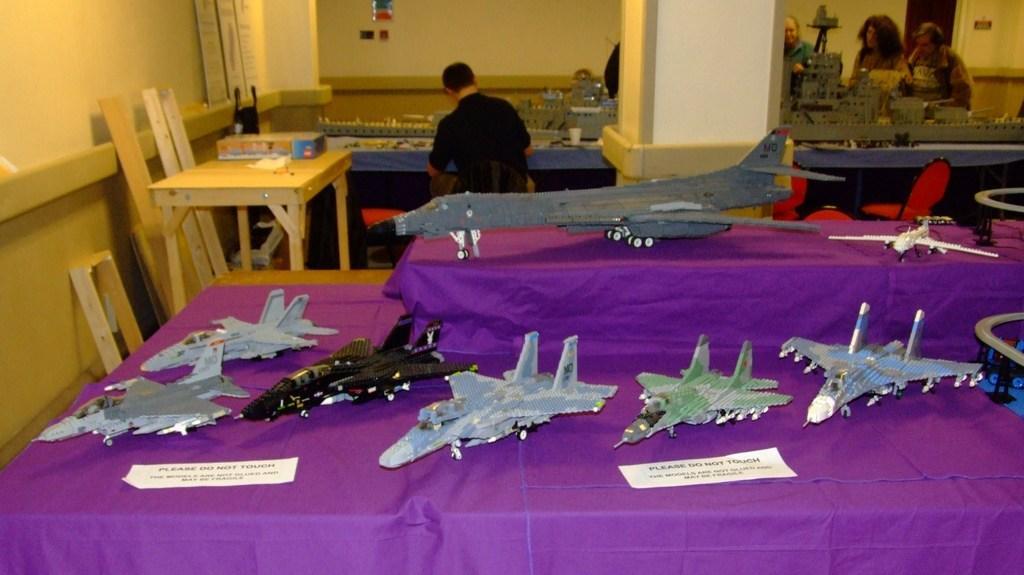Please provide a concise description of this image. In this picture we can see some toys like aeroplanes of different shapes are on the table and behind the table there are some people who are standing around the tables on which there are some things. 